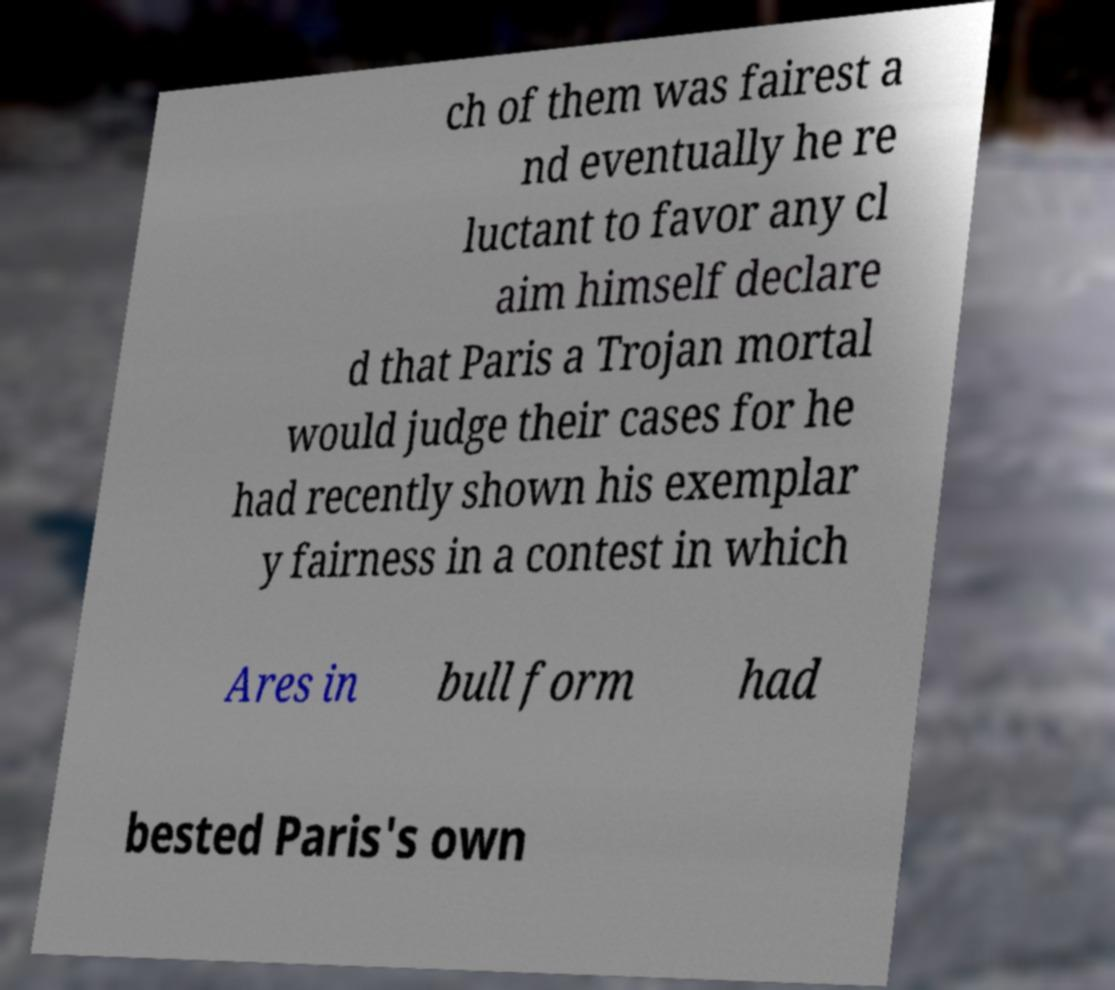Can you read and provide the text displayed in the image?This photo seems to have some interesting text. Can you extract and type it out for me? ch of them was fairest a nd eventually he re luctant to favor any cl aim himself declare d that Paris a Trojan mortal would judge their cases for he had recently shown his exemplar y fairness in a contest in which Ares in bull form had bested Paris's own 